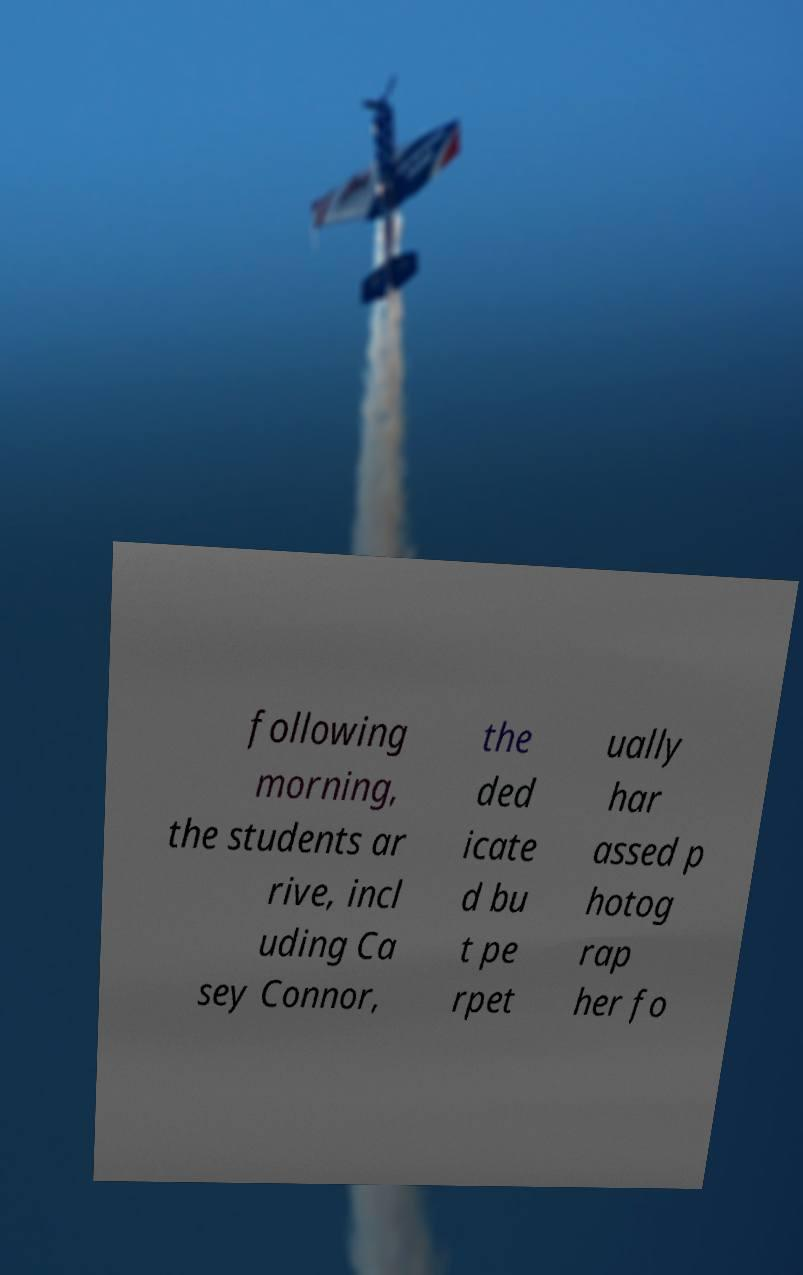Please read and relay the text visible in this image. What does it say? following morning, the students ar rive, incl uding Ca sey Connor, the ded icate d bu t pe rpet ually har assed p hotog rap her fo 